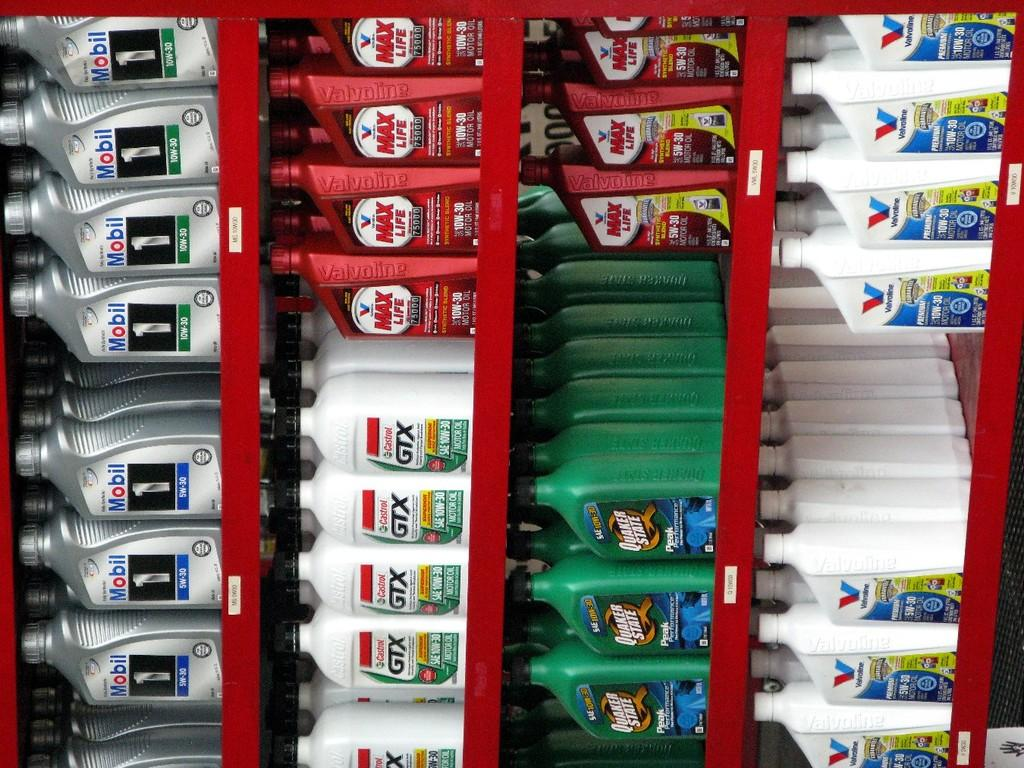<image>
Create a compact narrative representing the image presented. Various oils such as GTX and Mobil are on a red shelf. 